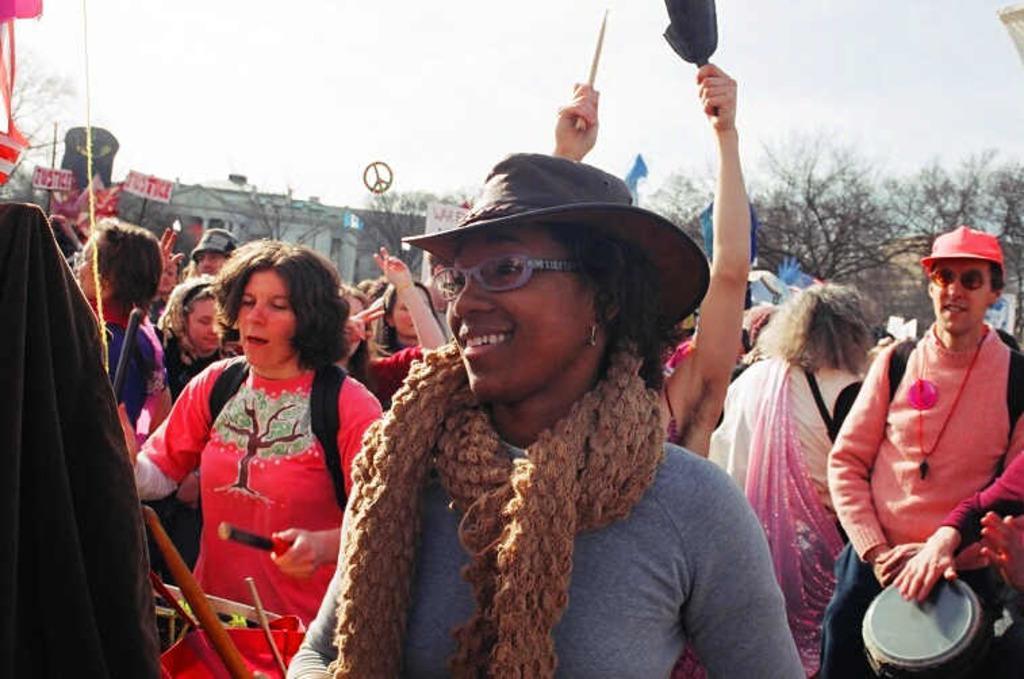Please provide a concise description of this image. In this image I can see some people. I can see a person holding something in the hands. In the background, I can see the buildings, trees and the sky. 